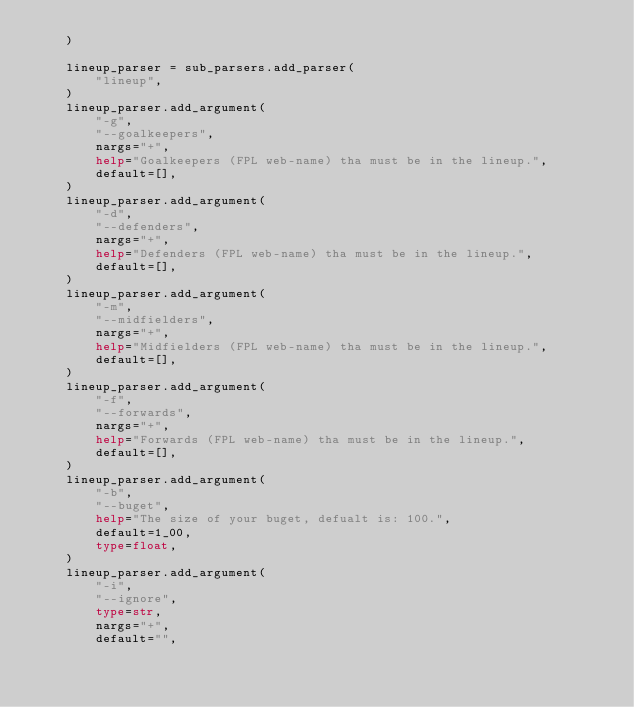Convert code to text. <code><loc_0><loc_0><loc_500><loc_500><_Python_>    )

    lineup_parser = sub_parsers.add_parser(
        "lineup",
    )
    lineup_parser.add_argument(
        "-g",
        "--goalkeepers",
        nargs="+",
        help="Goalkeepers (FPL web-name) tha must be in the lineup.",
        default=[],
    )
    lineup_parser.add_argument(
        "-d",
        "--defenders",
        nargs="+",
        help="Defenders (FPL web-name) tha must be in the lineup.",
        default=[],
    )
    lineup_parser.add_argument(
        "-m",
        "--midfielders",
        nargs="+",
        help="Midfielders (FPL web-name) tha must be in the lineup.",
        default=[],
    )
    lineup_parser.add_argument(
        "-f",
        "--forwards",
        nargs="+",
        help="Forwards (FPL web-name) tha must be in the lineup.",
        default=[],
    )
    lineup_parser.add_argument(
        "-b",
        "--buget",
        help="The size of your buget, defualt is: 100.",
        default=1_00,
        type=float,
    )
    lineup_parser.add_argument(
        "-i",
        "--ignore",
        type=str,
        nargs="+",
        default="",</code> 